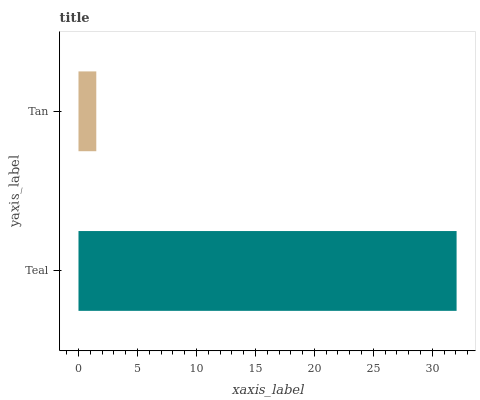Is Tan the minimum?
Answer yes or no. Yes. Is Teal the maximum?
Answer yes or no. Yes. Is Tan the maximum?
Answer yes or no. No. Is Teal greater than Tan?
Answer yes or no. Yes. Is Tan less than Teal?
Answer yes or no. Yes. Is Tan greater than Teal?
Answer yes or no. No. Is Teal less than Tan?
Answer yes or no. No. Is Teal the high median?
Answer yes or no. Yes. Is Tan the low median?
Answer yes or no. Yes. Is Tan the high median?
Answer yes or no. No. Is Teal the low median?
Answer yes or no. No. 